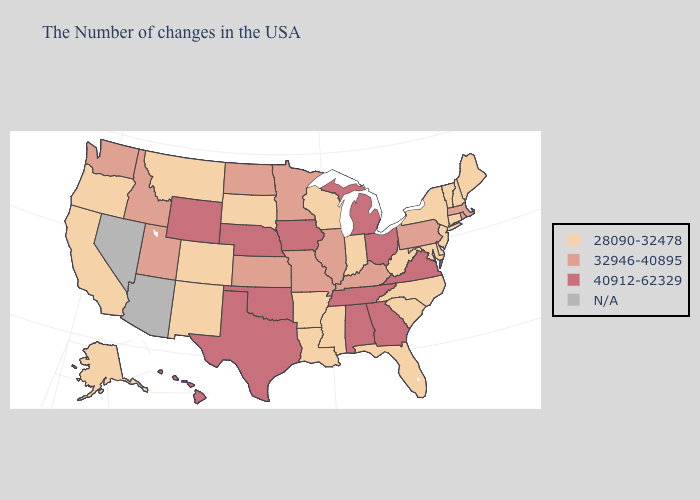What is the value of South Carolina?
Answer briefly. 28090-32478. Name the states that have a value in the range 28090-32478?
Be succinct. Maine, New Hampshire, Vermont, Connecticut, New York, New Jersey, Delaware, Maryland, North Carolina, South Carolina, West Virginia, Florida, Indiana, Wisconsin, Mississippi, Louisiana, Arkansas, South Dakota, Colorado, New Mexico, Montana, California, Oregon, Alaska. Name the states that have a value in the range 40912-62329?
Give a very brief answer. Virginia, Ohio, Georgia, Michigan, Alabama, Tennessee, Iowa, Nebraska, Oklahoma, Texas, Wyoming, Hawaii. Among the states that border North Dakota , does Minnesota have the lowest value?
Be succinct. No. Name the states that have a value in the range 32946-40895?
Answer briefly. Massachusetts, Rhode Island, Pennsylvania, Kentucky, Illinois, Missouri, Minnesota, Kansas, North Dakota, Utah, Idaho, Washington. Among the states that border South Dakota , does North Dakota have the highest value?
Answer briefly. No. Does Georgia have the highest value in the South?
Answer briefly. Yes. Among the states that border North Dakota , does Minnesota have the highest value?
Quick response, please. Yes. What is the value of Hawaii?
Answer briefly. 40912-62329. Does the first symbol in the legend represent the smallest category?
Give a very brief answer. Yes. Among the states that border New Jersey , which have the highest value?
Give a very brief answer. Pennsylvania. Which states have the lowest value in the South?
Give a very brief answer. Delaware, Maryland, North Carolina, South Carolina, West Virginia, Florida, Mississippi, Louisiana, Arkansas. Among the states that border Nebraska , does Iowa have the highest value?
Short answer required. Yes. Name the states that have a value in the range N/A?
Write a very short answer. Arizona, Nevada. 